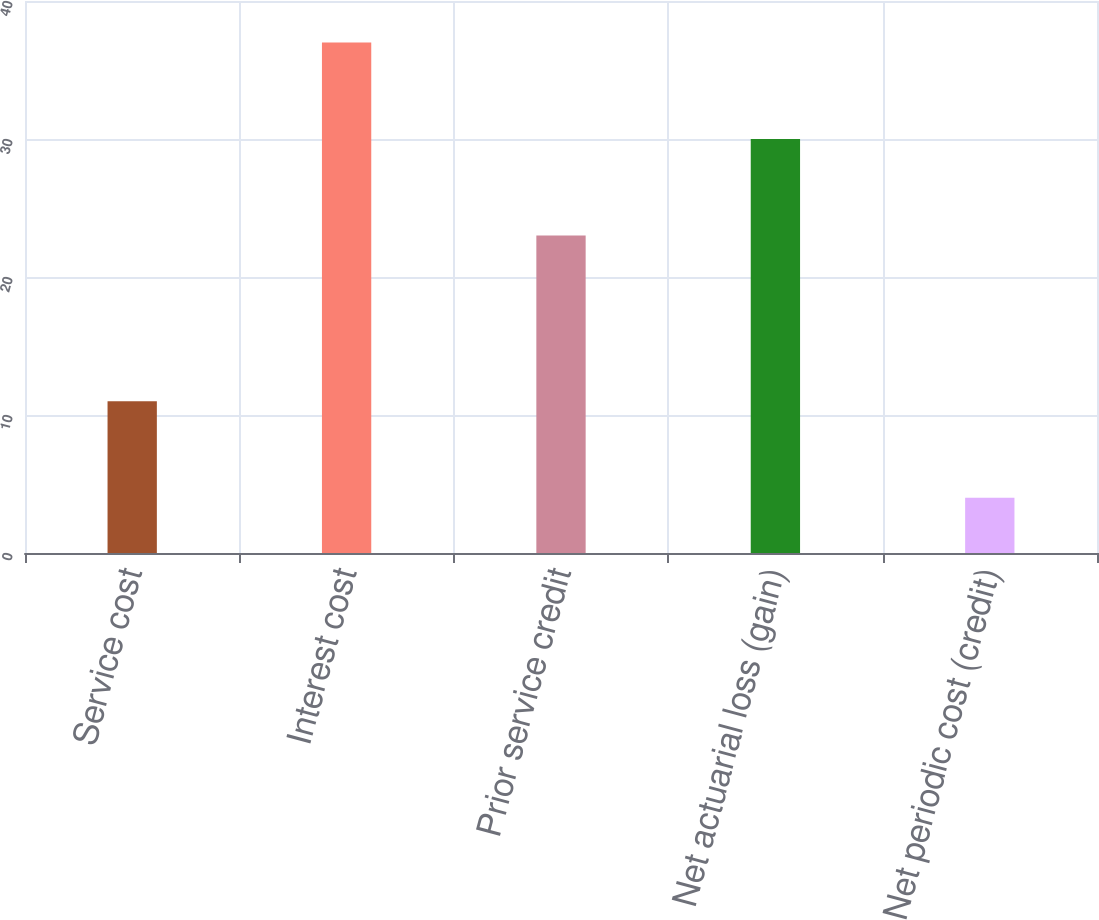Convert chart to OTSL. <chart><loc_0><loc_0><loc_500><loc_500><bar_chart><fcel>Service cost<fcel>Interest cost<fcel>Prior service credit<fcel>Net actuarial loss (gain)<fcel>Net periodic cost (credit)<nl><fcel>11<fcel>37<fcel>23<fcel>30<fcel>4<nl></chart> 